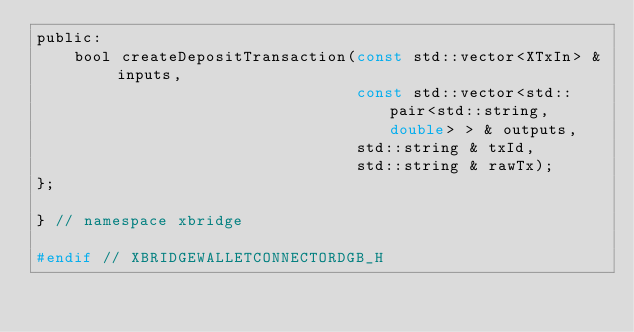<code> <loc_0><loc_0><loc_500><loc_500><_C_>public:
    bool createDepositTransaction(const std::vector<XTxIn> & inputs,
                                  const std::vector<std::pair<std::string, double> > & outputs,
                                  std::string & txId,
                                  std::string & rawTx);
};

} // namespace xbridge

#endif // XBRIDGEWALLETCONNECTORDGB_H
</code> 